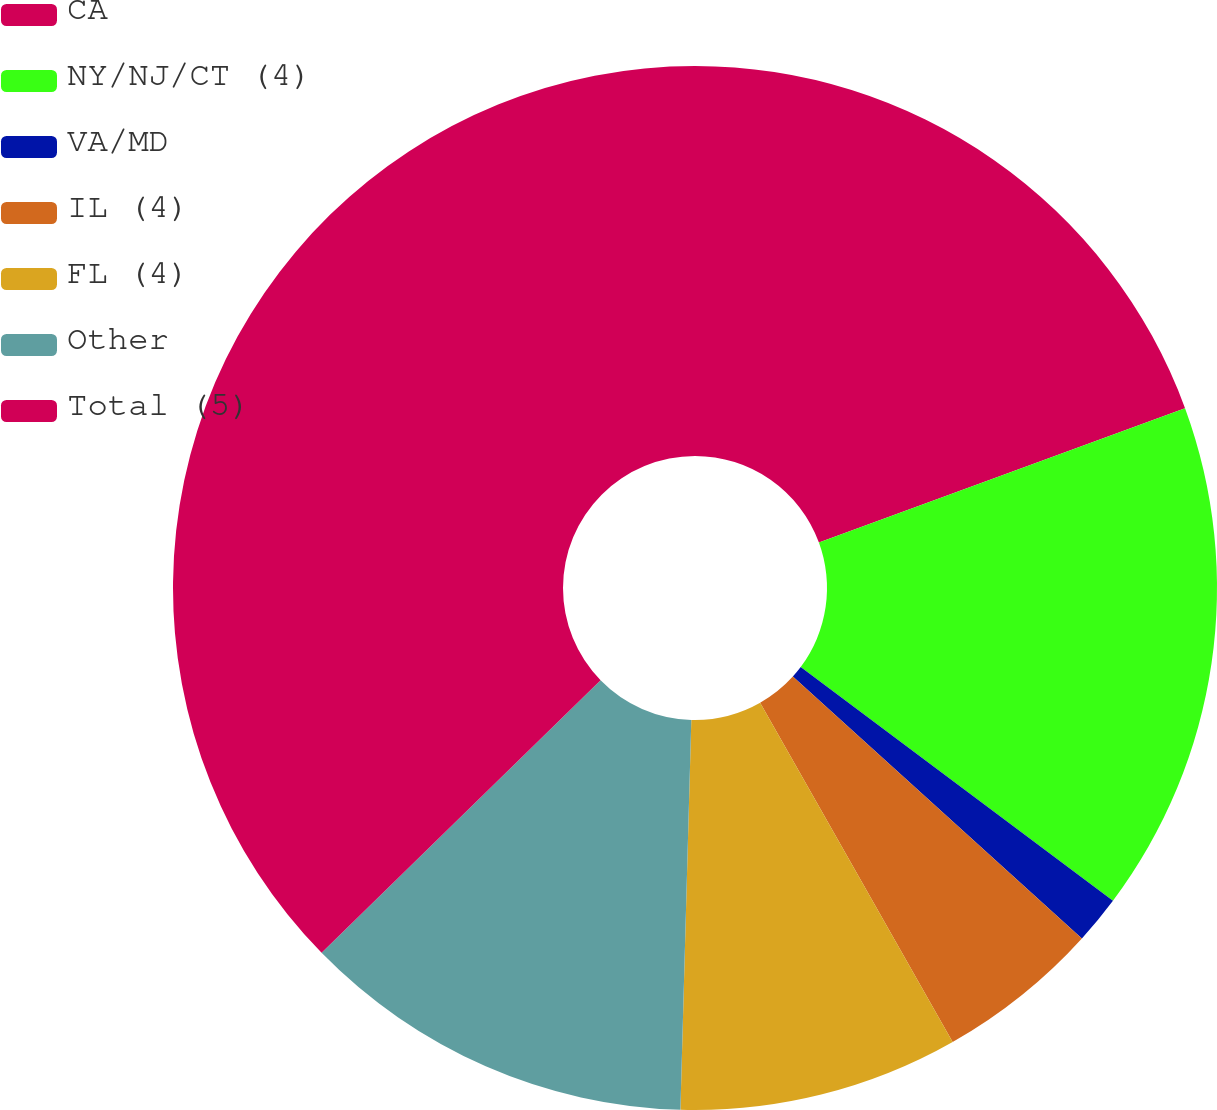Convert chart to OTSL. <chart><loc_0><loc_0><loc_500><loc_500><pie_chart><fcel>CA<fcel>NY/NJ/CT (4)<fcel>VA/MD<fcel>IL (4)<fcel>FL (4)<fcel>Other<fcel>Total (5)<nl><fcel>19.4%<fcel>15.82%<fcel>1.49%<fcel>5.07%<fcel>8.66%<fcel>12.24%<fcel>37.31%<nl></chart> 